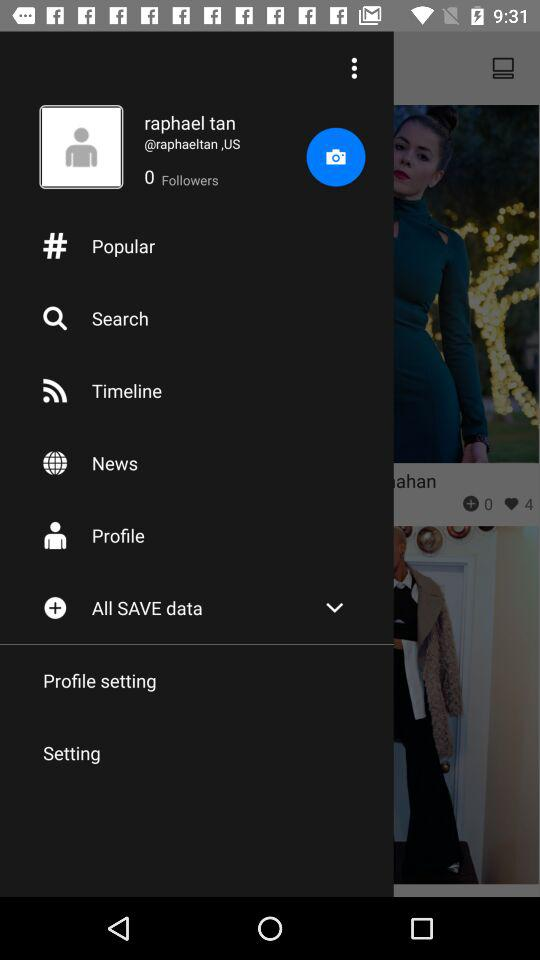How many followers are there? There are zero followers. 